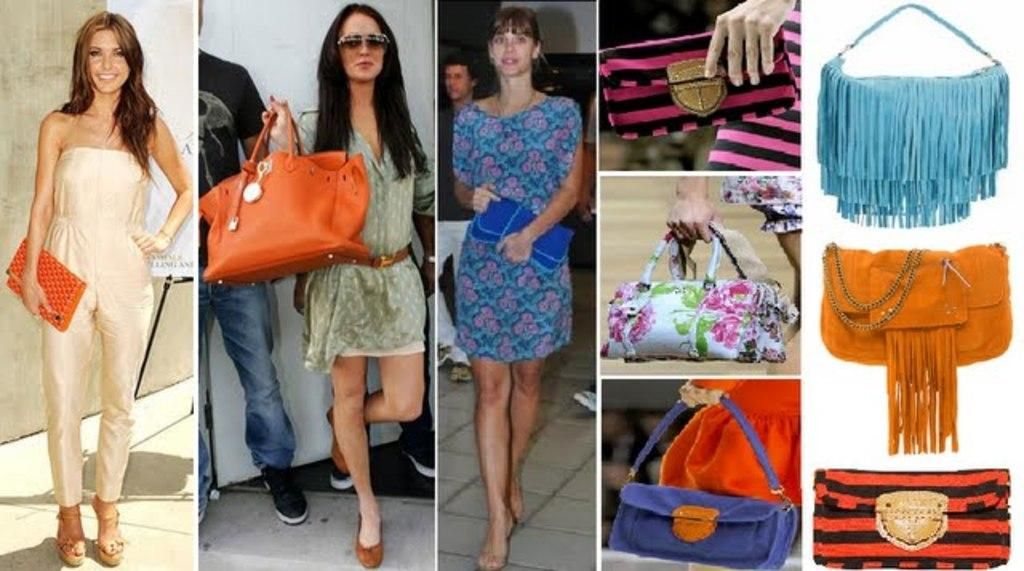What type of image is shown in the collage? The image is a collage of pictures. What are the women in the pictures doing? The women are standing in the pictures. What items are the women holding in the pictures? The women are holding purses and bags in the pictures. How many bags can be seen in the image? There are three bags visible in the image. What type of berry is being picked by the beetle in the image? There is no berry or beetle present in the image; it is a collage of pictures featuring women holding purses and bags. 